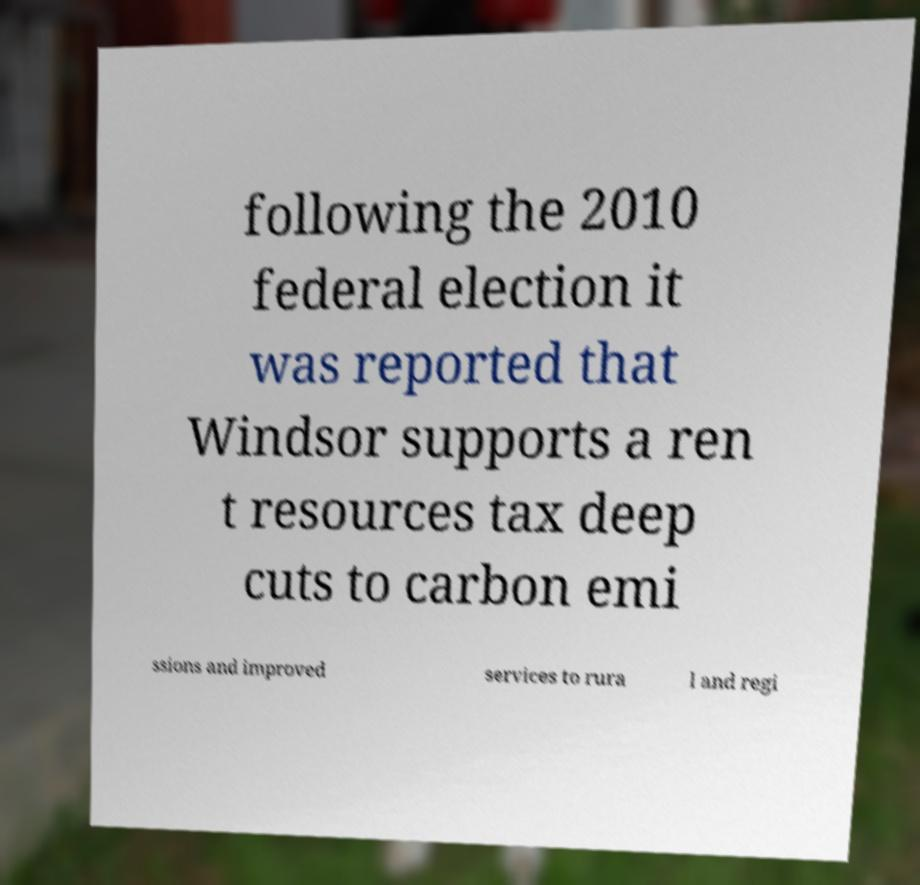There's text embedded in this image that I need extracted. Can you transcribe it verbatim? following the 2010 federal election it was reported that Windsor supports a ren t resources tax deep cuts to carbon emi ssions and improved services to rura l and regi 